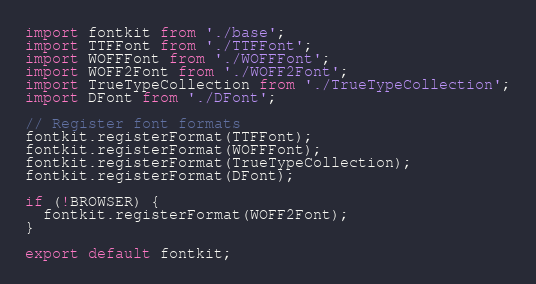<code> <loc_0><loc_0><loc_500><loc_500><_JavaScript_>import fontkit from './base';
import TTFFont from './TTFFont';
import WOFFFont from './WOFFFont';
import WOFF2Font from './WOFF2Font';
import TrueTypeCollection from './TrueTypeCollection';
import DFont from './DFont';

// Register font formats
fontkit.registerFormat(TTFFont);
fontkit.registerFormat(WOFFFont);
fontkit.registerFormat(TrueTypeCollection);
fontkit.registerFormat(DFont);

if (!BROWSER) {
  fontkit.registerFormat(WOFF2Font);
}

export default fontkit;
</code> 